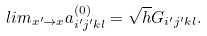Convert formula to latex. <formula><loc_0><loc_0><loc_500><loc_500>l i m _ { x ^ { \prime } \rightarrow x } a _ { i ^ { \prime } j ^ { \prime } k l } ^ { ( 0 ) } = \sqrt { h } G _ { i ^ { \prime } j ^ { \prime } k l } .</formula> 